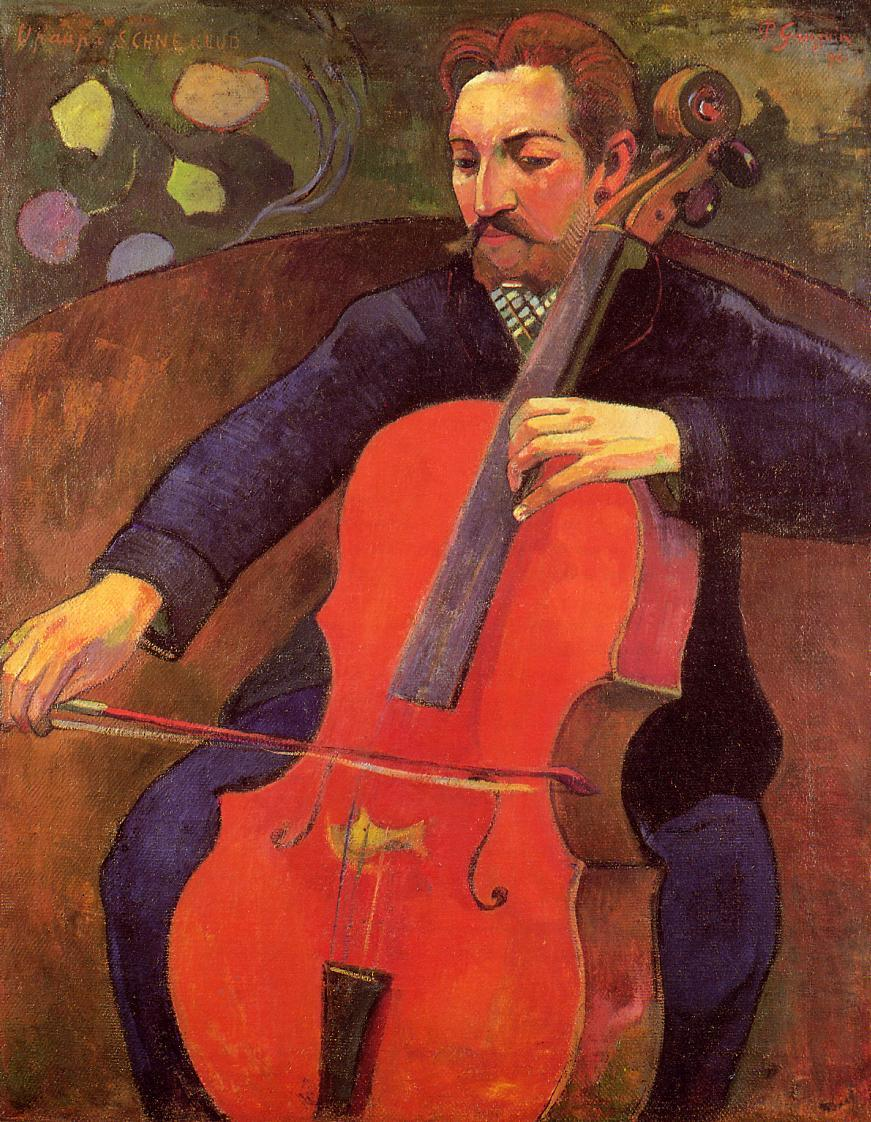Can you tell me more about the setting in this image? The setting of the image appears to be intentionally abstract, aligned with the expressionist style of the artwork. The background consists of bold, swirling colors and shapes that seem to blend into one another, creating a dynamic and almost surreal atmosphere. This abstraction draws focus to the central figure of the cellist and emphasizes the emotional intensity of the music being played. What could the colors in the background signify? The colors in the background, with their warm and vivid hues, could signify the emotive power of the music. Expressionist artists often use such colors to convey feelings rather than reality, so the vibrant oranges, reds, and yellows might represent the passion, joy, and energy of the performance. The blend of these hues with darker tones also adds a sense of depth and complexity, perhaps hinting at the intricate emotions intertwined with the music. Can you create a story about this musician and the painting? Once upon a time, in a quaint town bathed in the golden hues of autumn, lived a virtuoso cellist named Armand. Armand was passionate about his music, dedicating countless hours to perfecting his craft. One evening, he decided to perform an impromptu concert in a hidden corner of the nearby enchanted forest, known for its ancient trees and mystical aura.

As Armand played, the forest seemed to come alive. The melodies he created resonated with the rustling leaves and chirping birds, weaving a tapestry of sound that enchanted every creature in the vicinity. Unbeknownst to Armand, a gifted artist who often depicted the magic of that very forest was watching him play from a distance. Captivated by the blend of nature and music, the artist painted a masterpiece to capture the moment where music and nature united in perfect harmony.

Years later, this painting, known as 'The Enchanted Melody,' remained a testament to the unspoken bond between the cellist and the forest. It symbolized the profound impact of music on the natural world, and to this day, visitors to the artist's gallery feel the mystical connection whenever they gaze upon the image. 